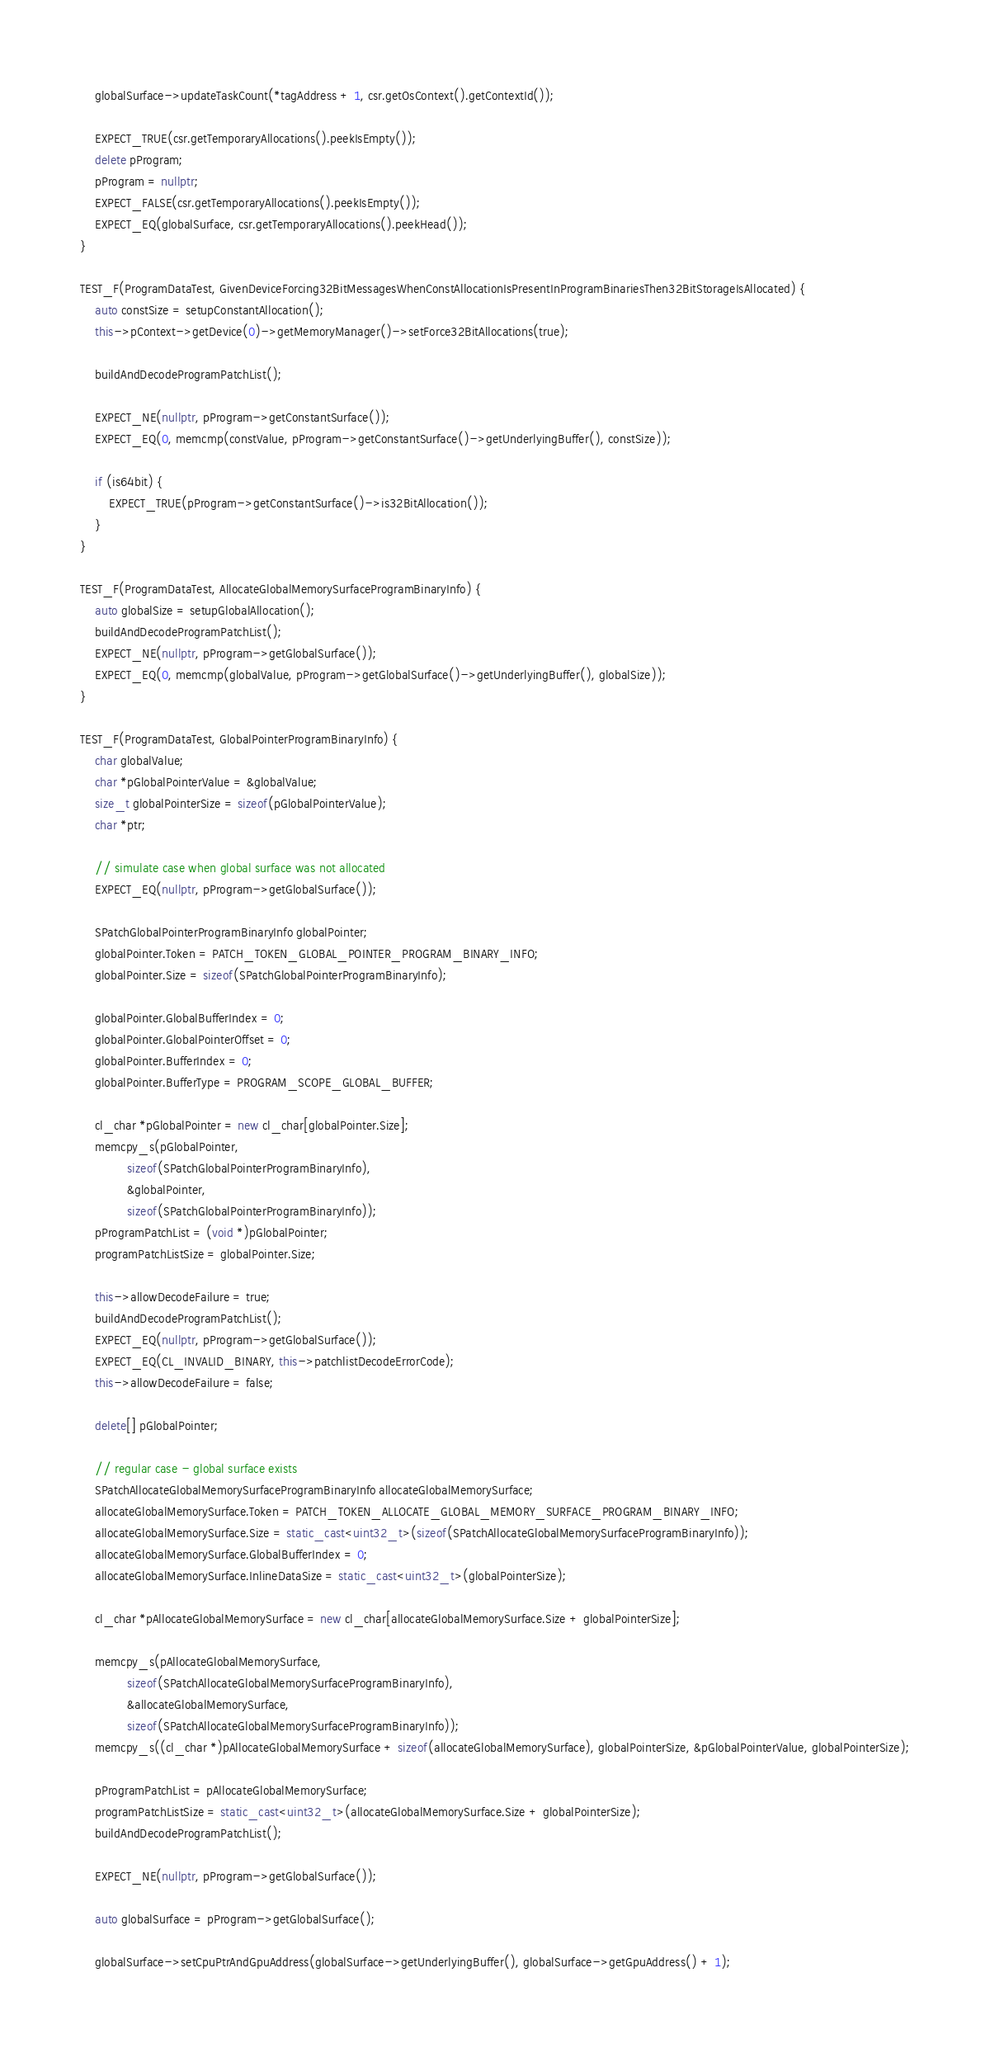<code> <loc_0><loc_0><loc_500><loc_500><_C++_>    globalSurface->updateTaskCount(*tagAddress + 1, csr.getOsContext().getContextId());

    EXPECT_TRUE(csr.getTemporaryAllocations().peekIsEmpty());
    delete pProgram;
    pProgram = nullptr;
    EXPECT_FALSE(csr.getTemporaryAllocations().peekIsEmpty());
    EXPECT_EQ(globalSurface, csr.getTemporaryAllocations().peekHead());
}

TEST_F(ProgramDataTest, GivenDeviceForcing32BitMessagesWhenConstAllocationIsPresentInProgramBinariesThen32BitStorageIsAllocated) {
    auto constSize = setupConstantAllocation();
    this->pContext->getDevice(0)->getMemoryManager()->setForce32BitAllocations(true);

    buildAndDecodeProgramPatchList();

    EXPECT_NE(nullptr, pProgram->getConstantSurface());
    EXPECT_EQ(0, memcmp(constValue, pProgram->getConstantSurface()->getUnderlyingBuffer(), constSize));

    if (is64bit) {
        EXPECT_TRUE(pProgram->getConstantSurface()->is32BitAllocation());
    }
}

TEST_F(ProgramDataTest, AllocateGlobalMemorySurfaceProgramBinaryInfo) {
    auto globalSize = setupGlobalAllocation();
    buildAndDecodeProgramPatchList();
    EXPECT_NE(nullptr, pProgram->getGlobalSurface());
    EXPECT_EQ(0, memcmp(globalValue, pProgram->getGlobalSurface()->getUnderlyingBuffer(), globalSize));
}

TEST_F(ProgramDataTest, GlobalPointerProgramBinaryInfo) {
    char globalValue;
    char *pGlobalPointerValue = &globalValue;
    size_t globalPointerSize = sizeof(pGlobalPointerValue);
    char *ptr;

    // simulate case when global surface was not allocated
    EXPECT_EQ(nullptr, pProgram->getGlobalSurface());

    SPatchGlobalPointerProgramBinaryInfo globalPointer;
    globalPointer.Token = PATCH_TOKEN_GLOBAL_POINTER_PROGRAM_BINARY_INFO;
    globalPointer.Size = sizeof(SPatchGlobalPointerProgramBinaryInfo);

    globalPointer.GlobalBufferIndex = 0;
    globalPointer.GlobalPointerOffset = 0;
    globalPointer.BufferIndex = 0;
    globalPointer.BufferType = PROGRAM_SCOPE_GLOBAL_BUFFER;

    cl_char *pGlobalPointer = new cl_char[globalPointer.Size];
    memcpy_s(pGlobalPointer,
             sizeof(SPatchGlobalPointerProgramBinaryInfo),
             &globalPointer,
             sizeof(SPatchGlobalPointerProgramBinaryInfo));
    pProgramPatchList = (void *)pGlobalPointer;
    programPatchListSize = globalPointer.Size;

    this->allowDecodeFailure = true;
    buildAndDecodeProgramPatchList();
    EXPECT_EQ(nullptr, pProgram->getGlobalSurface());
    EXPECT_EQ(CL_INVALID_BINARY, this->patchlistDecodeErrorCode);
    this->allowDecodeFailure = false;

    delete[] pGlobalPointer;

    // regular case - global surface exists
    SPatchAllocateGlobalMemorySurfaceProgramBinaryInfo allocateGlobalMemorySurface;
    allocateGlobalMemorySurface.Token = PATCH_TOKEN_ALLOCATE_GLOBAL_MEMORY_SURFACE_PROGRAM_BINARY_INFO;
    allocateGlobalMemorySurface.Size = static_cast<uint32_t>(sizeof(SPatchAllocateGlobalMemorySurfaceProgramBinaryInfo));
    allocateGlobalMemorySurface.GlobalBufferIndex = 0;
    allocateGlobalMemorySurface.InlineDataSize = static_cast<uint32_t>(globalPointerSize);

    cl_char *pAllocateGlobalMemorySurface = new cl_char[allocateGlobalMemorySurface.Size + globalPointerSize];

    memcpy_s(pAllocateGlobalMemorySurface,
             sizeof(SPatchAllocateGlobalMemorySurfaceProgramBinaryInfo),
             &allocateGlobalMemorySurface,
             sizeof(SPatchAllocateGlobalMemorySurfaceProgramBinaryInfo));
    memcpy_s((cl_char *)pAllocateGlobalMemorySurface + sizeof(allocateGlobalMemorySurface), globalPointerSize, &pGlobalPointerValue, globalPointerSize);

    pProgramPatchList = pAllocateGlobalMemorySurface;
    programPatchListSize = static_cast<uint32_t>(allocateGlobalMemorySurface.Size + globalPointerSize);
    buildAndDecodeProgramPatchList();

    EXPECT_NE(nullptr, pProgram->getGlobalSurface());

    auto globalSurface = pProgram->getGlobalSurface();

    globalSurface->setCpuPtrAndGpuAddress(globalSurface->getUnderlyingBuffer(), globalSurface->getGpuAddress() + 1);</code> 